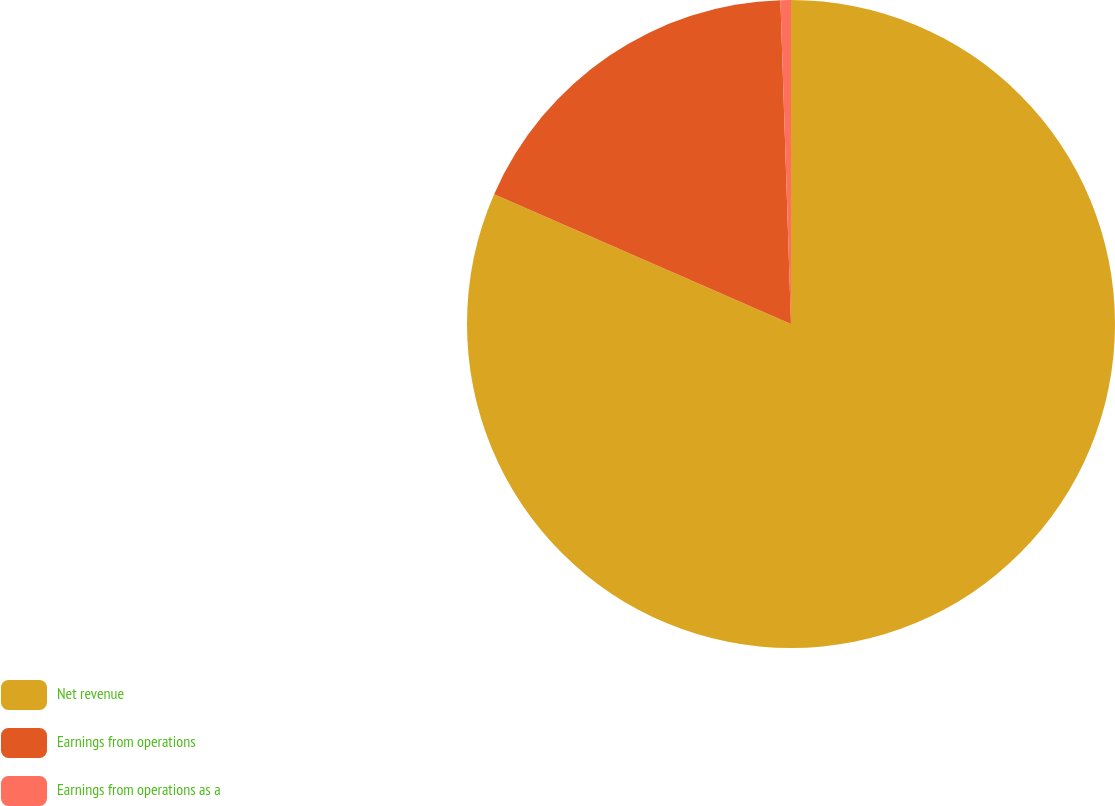Convert chart to OTSL. <chart><loc_0><loc_0><loc_500><loc_500><pie_chart><fcel>Net revenue<fcel>Earnings from operations<fcel>Earnings from operations as a<nl><fcel>81.56%<fcel>17.92%<fcel>0.52%<nl></chart> 